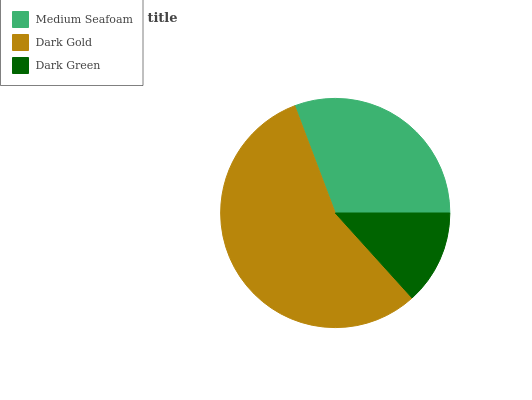Is Dark Green the minimum?
Answer yes or no. Yes. Is Dark Gold the maximum?
Answer yes or no. Yes. Is Dark Gold the minimum?
Answer yes or no. No. Is Dark Green the maximum?
Answer yes or no. No. Is Dark Gold greater than Dark Green?
Answer yes or no. Yes. Is Dark Green less than Dark Gold?
Answer yes or no. Yes. Is Dark Green greater than Dark Gold?
Answer yes or no. No. Is Dark Gold less than Dark Green?
Answer yes or no. No. Is Medium Seafoam the high median?
Answer yes or no. Yes. Is Medium Seafoam the low median?
Answer yes or no. Yes. Is Dark Green the high median?
Answer yes or no. No. Is Dark Green the low median?
Answer yes or no. No. 